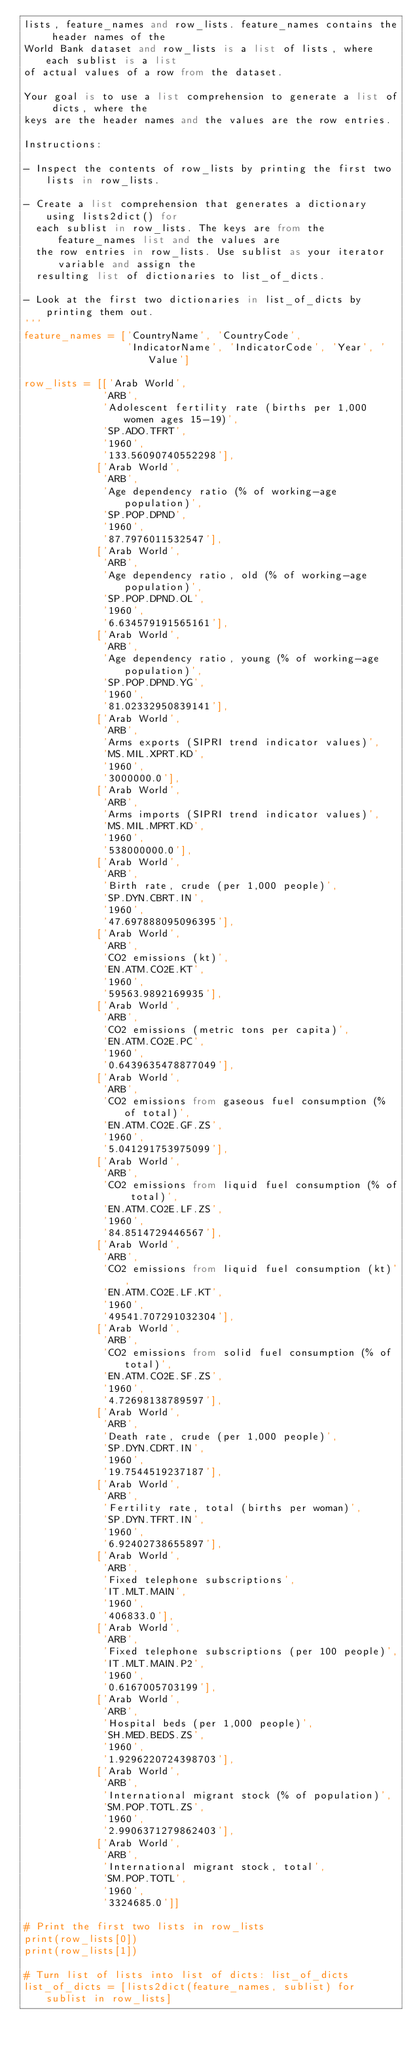<code> <loc_0><loc_0><loc_500><loc_500><_Python_>lists, feature_names and row_lists. feature_names contains the header names of the
World Bank dataset and row_lists is a list of lists, where each sublist is a list
of actual values of a row from the dataset.

Your goal is to use a list comprehension to generate a list of dicts, where the
keys are the header names and the values are the row entries.

Instructions:

- Inspect the contents of row_lists by printing the first two lists in row_lists.

- Create a list comprehension that generates a dictionary using lists2dict() for
  each sublist in row_lists. The keys are from the feature_names list and the values are
  the row entries in row_lists. Use sublist as your iterator variable and assign the
  resulting list of dictionaries to list_of_dicts.

- Look at the first two dictionaries in list_of_dicts by printing them out.
'''
feature_names = ['CountryName', 'CountryCode',
                 'IndicatorName', 'IndicatorCode', 'Year', 'Value']

row_lists = [['Arab World',
             'ARB',
             'Adolescent fertility rate (births per 1,000 women ages 15-19)',
             'SP.ADO.TFRT',
             '1960',
             '133.56090740552298'],
            ['Arab World',
             'ARB',
             'Age dependency ratio (% of working-age population)',
             'SP.POP.DPND',
             '1960',
             '87.7976011532547'],
            ['Arab World',
             'ARB',
             'Age dependency ratio, old (% of working-age population)',
             'SP.POP.DPND.OL',
             '1960',
             '6.634579191565161'],
            ['Arab World',
             'ARB',
             'Age dependency ratio, young (% of working-age population)',
             'SP.POP.DPND.YG',
             '1960',
             '81.02332950839141'],
            ['Arab World',
             'ARB',
             'Arms exports (SIPRI trend indicator values)',
             'MS.MIL.XPRT.KD',
             '1960',
             '3000000.0'],
            ['Arab World',
             'ARB',
             'Arms imports (SIPRI trend indicator values)',
             'MS.MIL.MPRT.KD',
             '1960',
             '538000000.0'],
            ['Arab World',
             'ARB',
             'Birth rate, crude (per 1,000 people)',
             'SP.DYN.CBRT.IN',
             '1960',
             '47.697888095096395'],
            ['Arab World',
             'ARB',
             'CO2 emissions (kt)',
             'EN.ATM.CO2E.KT',
             '1960',
             '59563.9892169935'],
            ['Arab World',
             'ARB',
             'CO2 emissions (metric tons per capita)',
             'EN.ATM.CO2E.PC',
             '1960',
             '0.6439635478877049'],
            ['Arab World',
             'ARB',
             'CO2 emissions from gaseous fuel consumption (% of total)',
             'EN.ATM.CO2E.GF.ZS',
             '1960',
             '5.041291753975099'],
            ['Arab World',
             'ARB',
             'CO2 emissions from liquid fuel consumption (% of total)',
             'EN.ATM.CO2E.LF.ZS',
             '1960',
             '84.8514729446567'],
            ['Arab World',
             'ARB',
             'CO2 emissions from liquid fuel consumption (kt)',
             'EN.ATM.CO2E.LF.KT',
             '1960',
             '49541.707291032304'],
            ['Arab World',
             'ARB',
             'CO2 emissions from solid fuel consumption (% of total)',
             'EN.ATM.CO2E.SF.ZS',
             '1960',
             '4.72698138789597'],
            ['Arab World',
             'ARB',
             'Death rate, crude (per 1,000 people)',
             'SP.DYN.CDRT.IN',
             '1960',
             '19.7544519237187'],
            ['Arab World',
             'ARB',
             'Fertility rate, total (births per woman)',
             'SP.DYN.TFRT.IN',
             '1960',
             '6.92402738655897'],
            ['Arab World',
             'ARB',
             'Fixed telephone subscriptions',
             'IT.MLT.MAIN',
             '1960',
             '406833.0'],
            ['Arab World',
             'ARB',
             'Fixed telephone subscriptions (per 100 people)',
             'IT.MLT.MAIN.P2',
             '1960',
             '0.6167005703199'],
            ['Arab World',
             'ARB',
             'Hospital beds (per 1,000 people)',
             'SH.MED.BEDS.ZS',
             '1960',
             '1.9296220724398703'],
            ['Arab World',
             'ARB',
             'International migrant stock (% of population)',
             'SM.POP.TOTL.ZS',
             '1960',
             '2.9906371279862403'],
            ['Arab World',
             'ARB',
             'International migrant stock, total',
             'SM.POP.TOTL',
             '1960',
             '3324685.0']]

# Print the first two lists in row_lists
print(row_lists[0])
print(row_lists[1])

# Turn list of lists into list of dicts: list_of_dicts
list_of_dicts = [lists2dict(feature_names, sublist) for sublist in row_lists]
</code> 